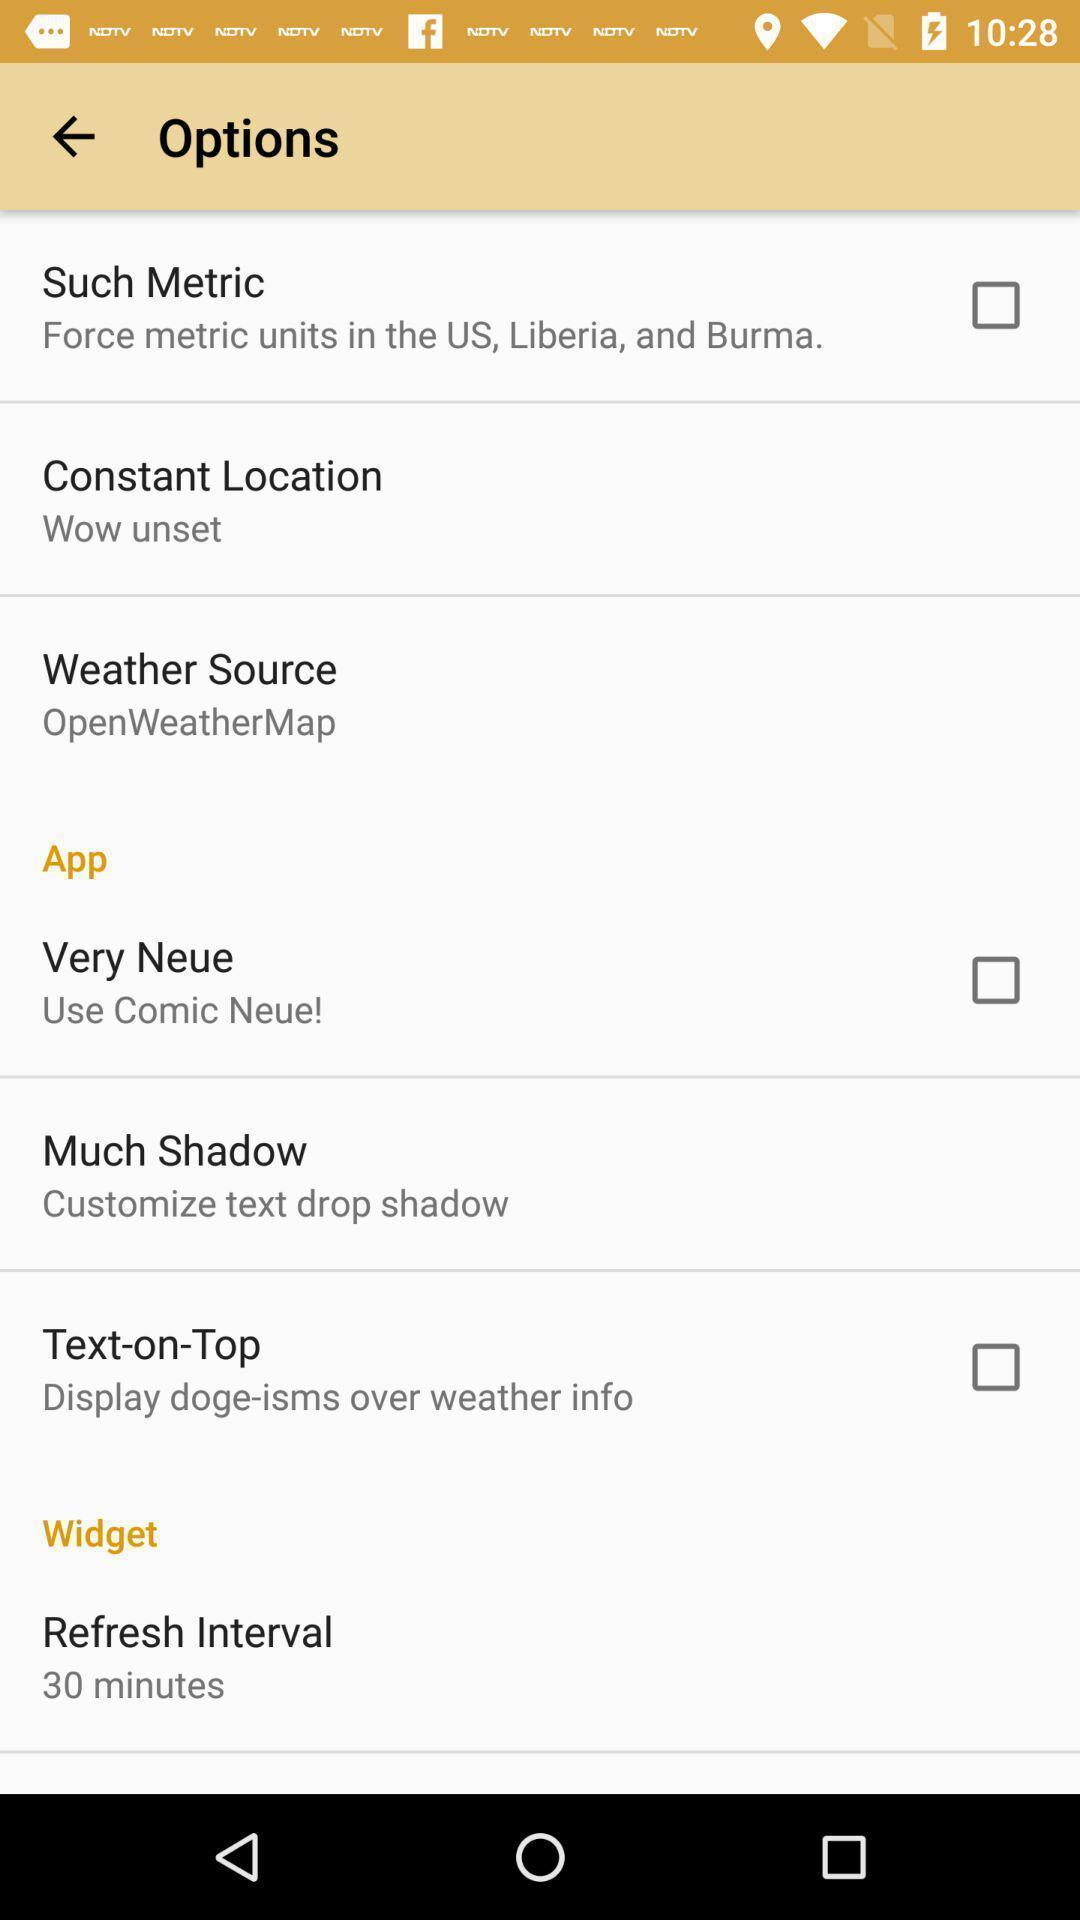Give me a narrative description of this picture. Screen showing options. 